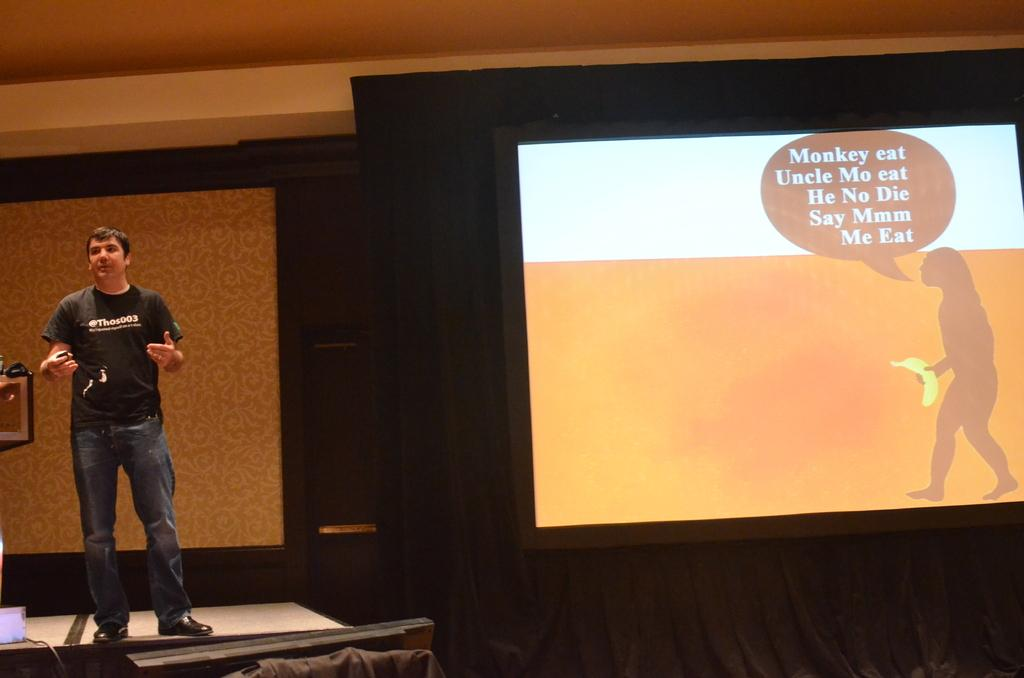What is the man in the image doing? The man is giving a speech on a stage. What can be seen behind the man? There is a wall and a screen displaying a presentation in the background. What is visible at the top of the image? The ceiling is visible at the top of the image. Can you see any toys on the stage with the man? There are no toys visible in the image; the man is giving a speech on a stage with a screen displaying a presentation in the background. 